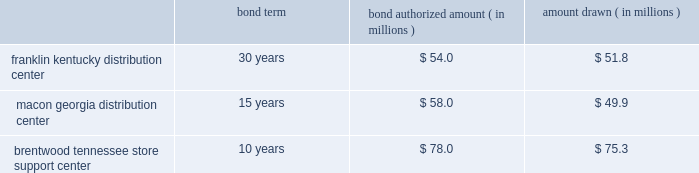The company entered into agreements with various governmental entities in the states of kentucky , georgia and tennessee to implement tax abatement plans related to its distribution center in franklin , kentucky ( simpson county ) , its distribution center in macon , georgia ( bibb county ) , and its store support center in brentwood , tennessee ( williamson county ) .
The tax abatement plans provide for reduction of real property taxes for specified time frames by legally transferring title to its real property in exchange for industrial revenue bonds .
This property was then leased back to the company .
No cash was exchanged .
The lease payments are equal to the amount of the payments on the bonds .
The tax abatement period extends through the term of the lease , which coincides with the maturity date of the bonds .
At any time , the company has the option to purchase the real property by paying off the bonds , plus $ 1 .
The terms and amounts authorized and drawn under each industrial revenue bond agreement are outlined as follows , as of december 30 , 2017 : bond term bond authorized amount ( in millions ) amount drawn ( in millions ) .
Due to the form of these transactions , the company has not recorded the bonds or the lease obligation associated with the sale lease-back transaction .
The original cost of the company 2019s property and equipment is recorded on the balance sheet and is being depreciated over its estimated useful life .
Capitalized software costs the company capitalizes certain costs related to the acquisition and development of software and amortizes these costs using the straight-line method over the estimated useful life of the software , which is three to five years .
Computer software consists of software developed for internal use and third-party software purchased for internal use .
A subsequent addition , modification or upgrade to internal-use software is capitalized to the extent that it enhances the software 2019s functionality or extends its useful life .
These costs are included in computer software and hardware in the accompanying consolidated balance sheets .
Certain software costs not meeting the criteria for capitalization are expensed as incurred .
Store closing costs the company regularly evaluates the performance of its stores and periodically closes those that are under-performing .
The company records a liability for costs associated with an exit or disposal activity when the liability is incurred , usually in the period the store closes .
Store closing costs were not significant to the results of operations for any of the fiscal years presented .
Leases assets under capital leases are amortized in accordance with the company 2019s normal depreciation policy for owned assets or over the lease term , if shorter , and the related charge to operations is included in depreciation expense in the consolidated statements of income .
Certain operating leases include rent increases during the lease term .
For these leases , the company recognizes the related rental expense on a straight-line basis over the term of the lease ( which includes the pre-opening period of construction , renovation , fixturing and merchandise placement ) and records the difference between the expense charged to operations and amounts paid as a deferred rent liability .
The company occasionally receives reimbursements from landlords to be used towards improving the related store to be leased .
Leasehold improvements are recorded at their gross costs , including items reimbursed by landlords .
Related reimbursements are deferred and amortized on a straight-line basis as a reduction of rent expense over the applicable lease term .
Note 2 - share-based compensation : share-based compensation includes stock option and restricted stock unit awards and certain transactions under the company 2019s espp .
Share-based compensation expense is recognized based on the grant date fair value of all stock option and restricted stock unit awards plus a discount on shares purchased by employees as a part of the espp .
The discount under the espp represents the difference between the purchase date market value and the employee 2019s purchase price. .
What was the total amount lost from the bond authorization to the withdrawn? 
Rationale: to find out the amount of money lost we must compare the authorization to the withdraw of all 3 bonds . then once you find the difference of these bonds you will add together the differences to get $ 13 million
Computations: ((54.0 - 51.8) + ((78.0 - 75.3) + (58.0 - 49.9)))
Answer: 13.0. 